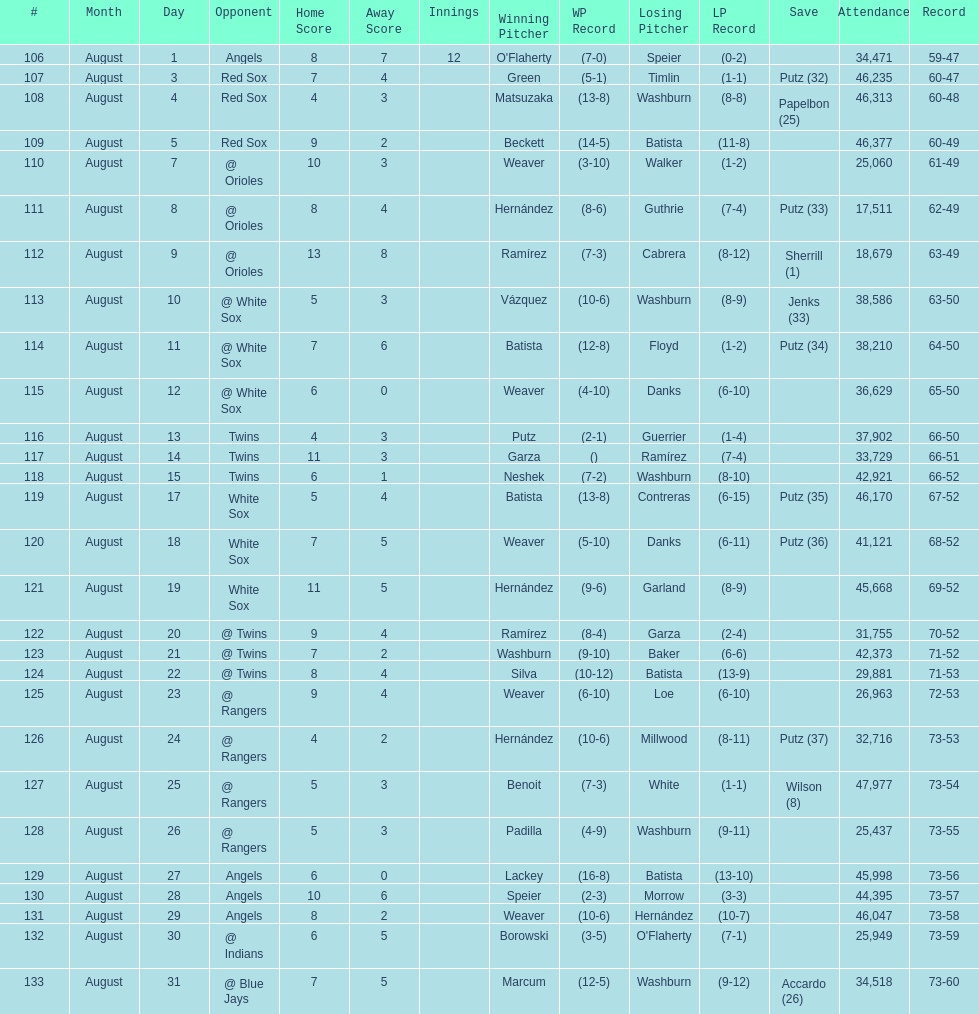Largest run differential 8. Help me parse the entirety of this table. {'header': ['#', 'Month', 'Day', 'Opponent', 'Home Score', 'Away Score', 'Innings', 'Winning Pitcher', 'WP Record', 'Losing Pitcher', 'LP Record', 'Save', 'Attendance', 'Record'], 'rows': [['106', 'August', '1', 'Angels', '8', '7', '12', "O'Flaherty", '(7-0)', 'Speier', '(0-2)', '', '34,471', '59-47'], ['107', 'August', '3', 'Red Sox', '7', '4', '', 'Green', '(5-1)', 'Timlin', '(1-1)', 'Putz (32)', '46,235', '60-47'], ['108', 'August', '4', 'Red Sox', '4', '3', '', 'Matsuzaka', '(13-8)', 'Washburn', '(8-8)', 'Papelbon (25)', '46,313', '60-48'], ['109', 'August', '5', 'Red Sox', '9', '2', '', 'Beckett', '(14-5)', 'Batista', '(11-8)', '', '46,377', '60-49'], ['110', 'August', '7', '@ Orioles', '10', '3', '', 'Weaver', '(3-10)', 'Walker', '(1-2)', '', '25,060', '61-49'], ['111', 'August', '8', '@ Orioles', '8', '4', '', 'Hernández', '(8-6)', 'Guthrie', '(7-4)', 'Putz (33)', '17,511', '62-49'], ['112', 'August', '9', '@ Orioles', '13', '8', '', 'Ramírez', '(7-3)', 'Cabrera', '(8-12)', 'Sherrill (1)', '18,679', '63-49'], ['113', 'August', '10', '@ White Sox', '5', '3', '', 'Vázquez', '(10-6)', 'Washburn', '(8-9)', 'Jenks (33)', '38,586', '63-50'], ['114', 'August', '11', '@ White Sox', '7', '6', '', 'Batista', '(12-8)', 'Floyd', '(1-2)', 'Putz (34)', '38,210', '64-50'], ['115', 'August', '12', '@ White Sox', '6', '0', '', 'Weaver', '(4-10)', 'Danks', '(6-10)', '', '36,629', '65-50'], ['116', 'August', '13', 'Twins', '4', '3', '', 'Putz', '(2-1)', 'Guerrier', '(1-4)', '', '37,902', '66-50'], ['117', 'August', '14', 'Twins', '11', '3', '', 'Garza', '()', 'Ramírez', '(7-4)', '', '33,729', '66-51'], ['118', 'August', '15', 'Twins', '6', '1', '', 'Neshek', '(7-2)', 'Washburn', '(8-10)', '', '42,921', '66-52'], ['119', 'August', '17', 'White Sox', '5', '4', '', 'Batista', '(13-8)', 'Contreras', '(6-15)', 'Putz (35)', '46,170', '67-52'], ['120', 'August', '18', 'White Sox', '7', '5', '', 'Weaver', '(5-10)', 'Danks', '(6-11)', 'Putz (36)', '41,121', '68-52'], ['121', 'August', '19', 'White Sox', '11', '5', '', 'Hernández', '(9-6)', 'Garland', '(8-9)', '', '45,668', '69-52'], ['122', 'August', '20', '@ Twins', '9', '4', '', 'Ramírez', '(8-4)', 'Garza', '(2-4)', '', '31,755', '70-52'], ['123', 'August', '21', '@ Twins', '7', '2', '', 'Washburn', '(9-10)', 'Baker', '(6-6)', '', '42,373', '71-52'], ['124', 'August', '22', '@ Twins', '8', '4', '', 'Silva', '(10-12)', 'Batista', '(13-9)', '', '29,881', '71-53'], ['125', 'August', '23', '@ Rangers', '9', '4', '', 'Weaver', '(6-10)', 'Loe', '(6-10)', '', '26,963', '72-53'], ['126', 'August', '24', '@ Rangers', '4', '2', '', 'Hernández', '(10-6)', 'Millwood', '(8-11)', 'Putz (37)', '32,716', '73-53'], ['127', 'August', '25', '@ Rangers', '5', '3', '', 'Benoit', '(7-3)', 'White', '(1-1)', 'Wilson (8)', '47,977', '73-54'], ['128', 'August', '26', '@ Rangers', '5', '3', '', 'Padilla', '(4-9)', 'Washburn', '(9-11)', '', '25,437', '73-55'], ['129', 'August', '27', 'Angels', '6', '0', '', 'Lackey', '(16-8)', 'Batista', '(13-10)', '', '45,998', '73-56'], ['130', 'August', '28', 'Angels', '10', '6', '', 'Speier', '(2-3)', 'Morrow', '(3-3)', '', '44,395', '73-57'], ['131', 'August', '29', 'Angels', '8', '2', '', 'Weaver', '(10-6)', 'Hernández', '(10-7)', '', '46,047', '73-58'], ['132', 'August', '30', '@ Indians', '6', '5', '', 'Borowski', '(3-5)', "O'Flaherty", '(7-1)', '', '25,949', '73-59'], ['133', 'August', '31', '@ Blue Jays', '7', '5', '', 'Marcum', '(12-5)', 'Washburn', '(9-12)', 'Accardo (26)', '34,518', '73-60']]} 